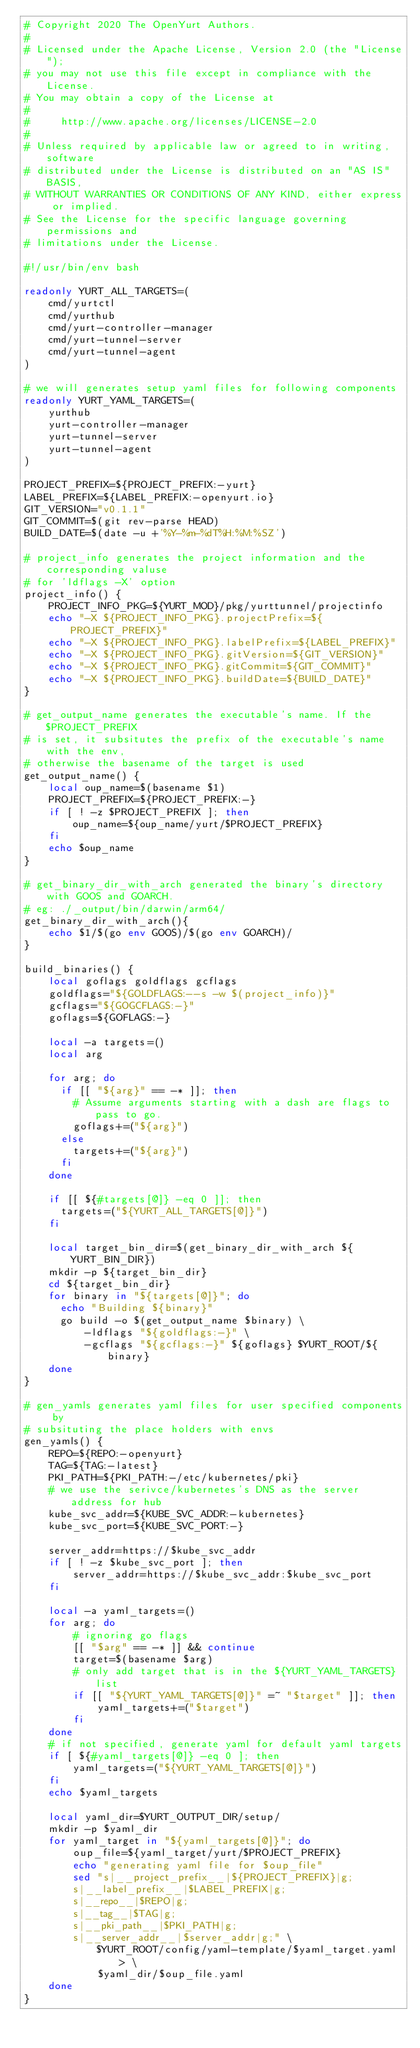<code> <loc_0><loc_0><loc_500><loc_500><_Bash_># Copyright 2020 The OpenYurt Authors.
# 
# Licensed under the Apache License, Version 2.0 (the "License");
# you may not use this file except in compliance with the License.
# You may obtain a copy of the License at
# 
#     http://www.apache.org/licenses/LICENSE-2.0
# 
# Unless required by applicable law or agreed to in writing, software
# distributed under the License is distributed on an "AS IS" BASIS,
# WITHOUT WARRANTIES OR CONDITIONS OF ANY KIND, either express or implied.
# See the License for the specific language governing permissions and
# limitations under the License.

#!/usr/bin/env bash

readonly YURT_ALL_TARGETS=(
    cmd/yurtctl
    cmd/yurthub
    cmd/yurt-controller-manager
    cmd/yurt-tunnel-server
    cmd/yurt-tunnel-agent
)

# we will generates setup yaml files for following components
readonly YURT_YAML_TARGETS=(
    yurthub
    yurt-controller-manager
    yurt-tunnel-server
    yurt-tunnel-agent
)

PROJECT_PREFIX=${PROJECT_PREFIX:-yurt}
LABEL_PREFIX=${LABEL_PREFIX:-openyurt.io}
GIT_VERSION="v0.1.1"
GIT_COMMIT=$(git rev-parse HEAD)
BUILD_DATE=$(date -u +'%Y-%m-%dT%H:%M:%SZ')

# project_info generates the project information and the corresponding valuse 
# for 'ldflags -X' option
project_info() {
    PROJECT_INFO_PKG=${YURT_MOD}/pkg/yurttunnel/projectinfo
    echo "-X ${PROJECT_INFO_PKG}.projectPrefix=${PROJECT_PREFIX}"
    echo "-X ${PROJECT_INFO_PKG}.labelPrefix=${LABEL_PREFIX}"
    echo "-X ${PROJECT_INFO_PKG}.gitVersion=${GIT_VERSION}"
    echo "-X ${PROJECT_INFO_PKG}.gitCommit=${GIT_COMMIT}"
    echo "-X ${PROJECT_INFO_PKG}.buildDate=${BUILD_DATE}"
}

# get_output_name generates the executable's name. If the $PROJECT_PREFIX
# is set, it subsitutes the prefix of the executable's name with the env, 
# otherwise the basename of the target is used
get_output_name() {
    local oup_name=$(basename $1)
    PROJECT_PREFIX=${PROJECT_PREFIX:-}
    if [ ! -z $PROJECT_PREFIX ]; then
        oup_name=${oup_name/yurt/$PROJECT_PREFIX}
    fi
    echo $oup_name
}

# get_binary_dir_with_arch generated the binary's directory with GOOS and GOARCH.
# eg: ./_output/bin/darwin/arm64/
get_binary_dir_with_arch(){
    echo $1/$(go env GOOS)/$(go env GOARCH)/
}

build_binaries() {
    local goflags goldflags gcflags
    goldflags="${GOLDFLAGS:--s -w $(project_info)}"
    gcflags="${GOGCFLAGS:-}"
    goflags=${GOFLAGS:-}

    local -a targets=()
    local arg

    for arg; do
      if [[ "${arg}" == -* ]]; then
        # Assume arguments starting with a dash are flags to pass to go.
        goflags+=("${arg}")
      else
        targets+=("${arg}")
      fi
    done

    if [[ ${#targets[@]} -eq 0 ]]; then
      targets=("${YURT_ALL_TARGETS[@]}")
    fi

    local target_bin_dir=$(get_binary_dir_with_arch ${YURT_BIN_DIR})
    mkdir -p ${target_bin_dir}
    cd ${target_bin_dir}
    for binary in "${targets[@]}"; do
      echo "Building ${binary}"
      go build -o $(get_output_name $binary) \
          -ldflags "${goldflags:-}" \
          -gcflags "${gcflags:-}" ${goflags} $YURT_ROOT/${binary}
    done
}

# gen_yamls generates yaml files for user specified components by 
# subsituting the place holders with envs
gen_yamls() {
    REPO=${REPO:-openyurt}
    TAG=${TAG:-latest}
    PKI_PATH=${PKI_PATH:-/etc/kubernetes/pki}
    # we use the serivce/kubernetes's DNS as the server address for hub
    kube_svc_addr=${KUBE_SVC_ADDR:-kubernetes}
    kube_svc_port=${KUBE_SVC_PORT:-}
    
    server_addr=https://$kube_svc_addr
    if [ ! -z $kube_svc_port ]; then
        server_addr=https://$kube_svc_addr:$kube_svc_port
    fi

    local -a yaml_targets=() 
    for arg; do
        # ignoring go flags 
        [[ "$arg" == -* ]] && continue
        target=$(basename $arg)
        # only add target that is in the ${YURT_YAML_TARGETS} list
        if [[ "${YURT_YAML_TARGETS[@]}" =~ "$target" ]]; then
            yaml_targets+=("$target")        
        fi
    done
    # if not specified, generate yaml for default yaml targets
    if [ ${#yaml_targets[@]} -eq 0 ]; then
        yaml_targets=("${YURT_YAML_TARGETS[@]}")
    fi
    echo $yaml_targets
    
    local yaml_dir=$YURT_OUTPUT_DIR/setup/
    mkdir -p $yaml_dir
    for yaml_target in "${yaml_targets[@]}"; do
        oup_file=${yaml_target/yurt/$PROJECT_PREFIX}
        echo "generating yaml file for $oup_file"
        sed "s|__project_prefix__|${PROJECT_PREFIX}|g;
        s|__label_prefix__|$LABEL_PREFIX|g;
        s|__repo__|$REPO|g;
        s|__tag__|$TAG|g;
        s|__pki_path__|$PKI_PATH|g;
        s|__server_addr__|$server_addr|g;" \
            $YURT_ROOT/config/yaml-template/$yaml_target.yaml > \
            $yaml_dir/$oup_file.yaml
    done
}
</code> 